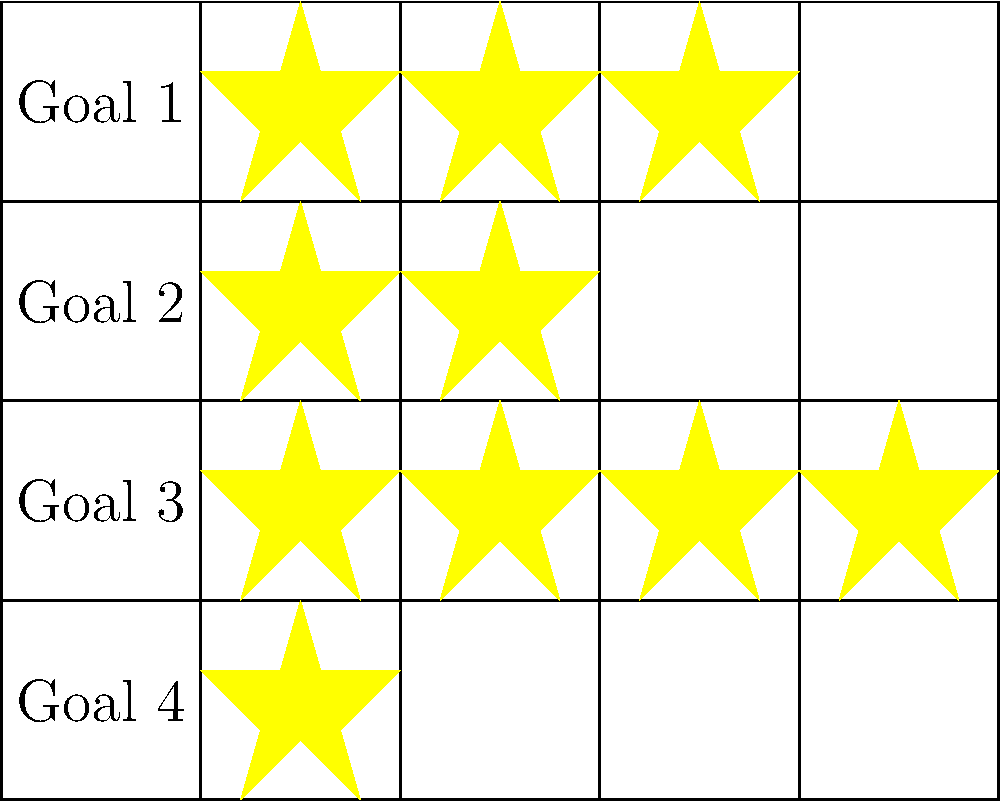Based on the reward chart shown, which goal has been completed the most times, and how many times has it been achieved? To answer this question, we need to analyze the visual representation of achievements in the reward chart:

1. The chart shows four goals (rows) and five potential achievements (columns) for each goal.
2. Each yellow star represents a completed achievement for that goal.
3. Let's count the stars for each goal:
   - Goal 1 (top row): 3 stars
   - Goal 2 (second row): 2 stars
   - Goal 3 (third row): 4 stars
   - Goal 4 (bottom row): 1 star
4. The goal with the most stars (achievements) is Goal 3, with 4 stars.

Therefore, Goal 3 has been completed the most times, achieving it 4 times.
Answer: Goal 3, 4 times 